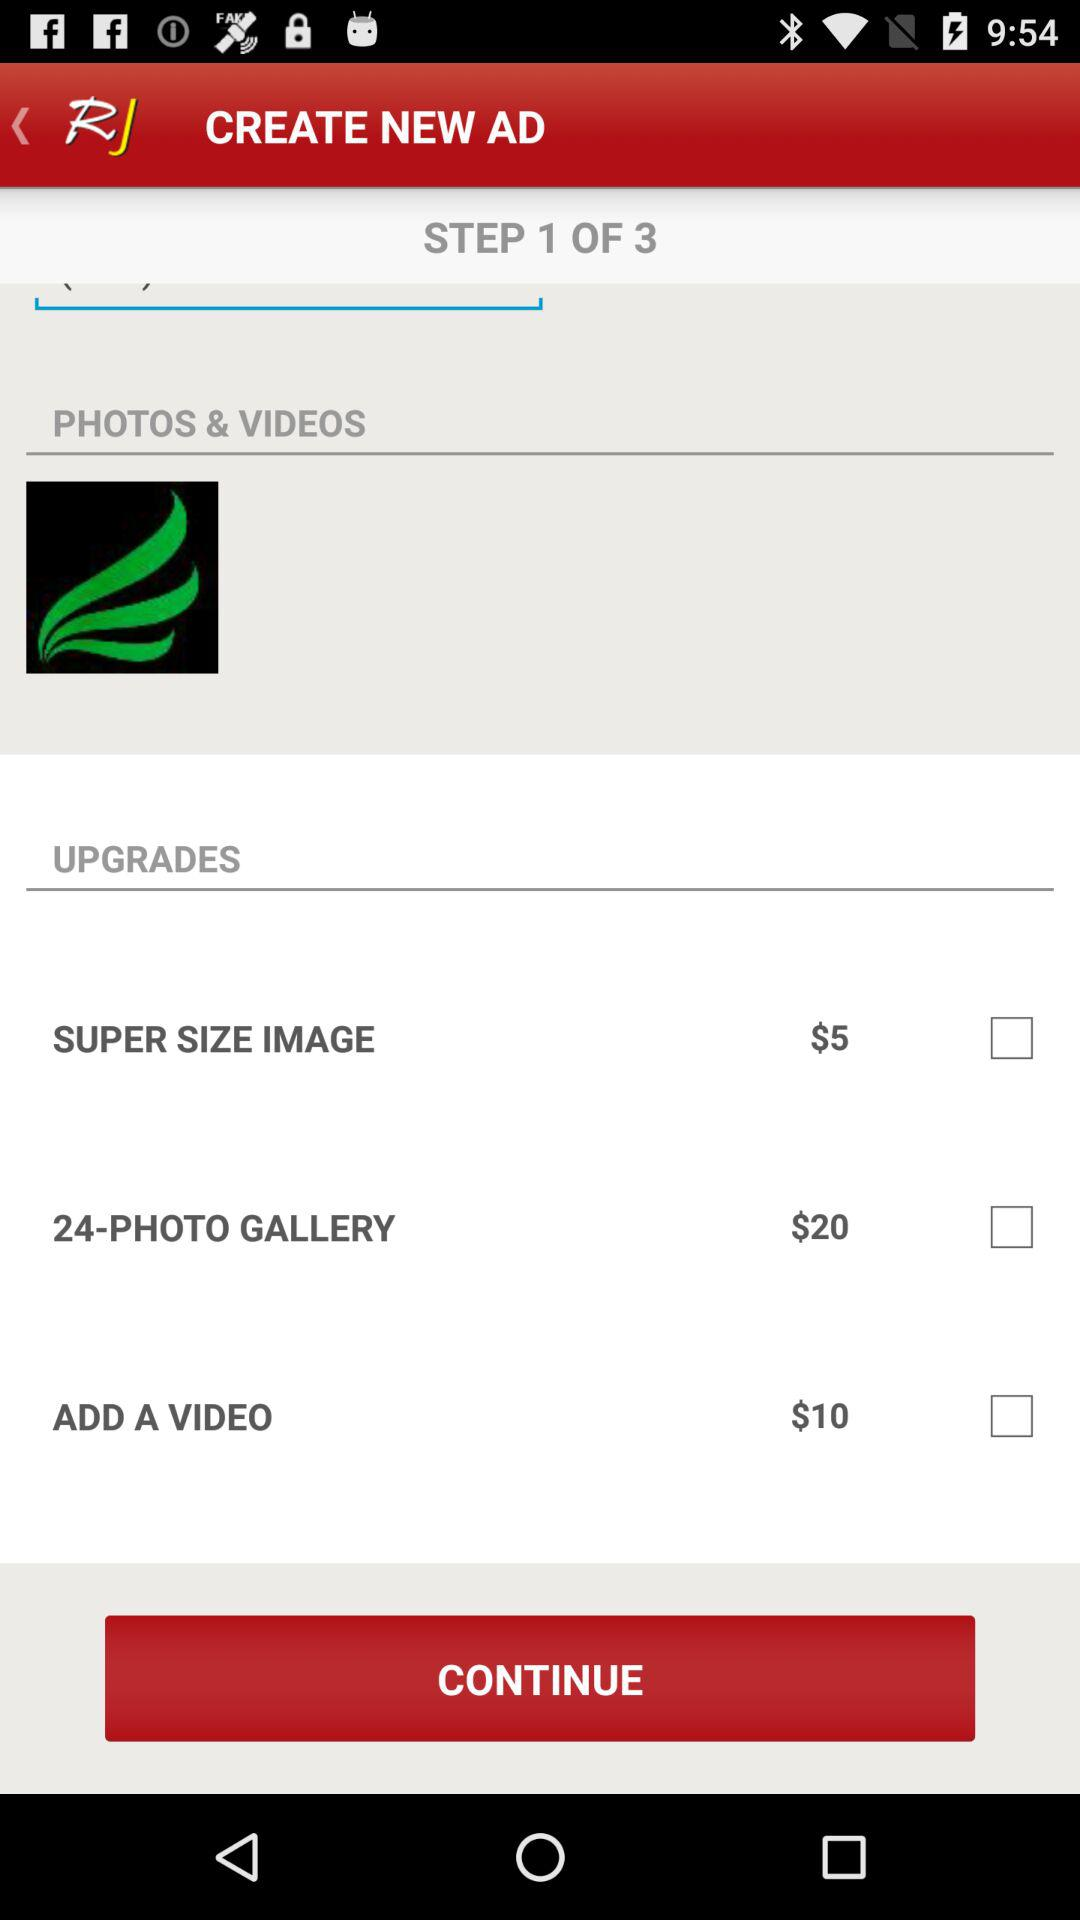What is the price of "SUPER SIZE IMAGE"? The price is $5. 